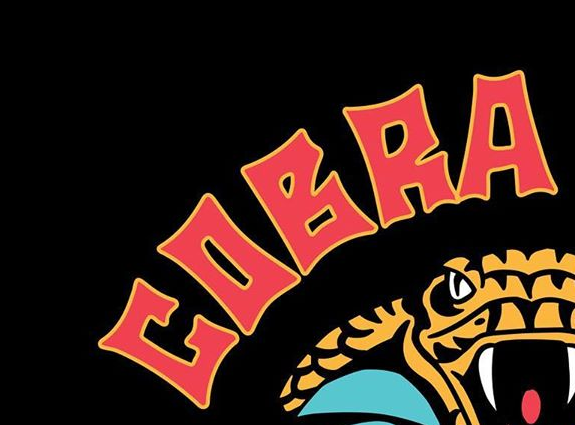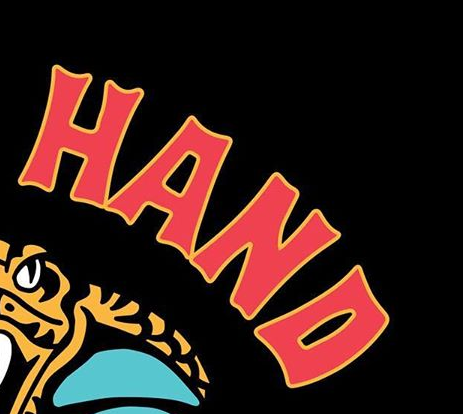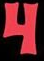Read the text from these images in sequence, separated by a semicolon. COBRA; HAND; 4 